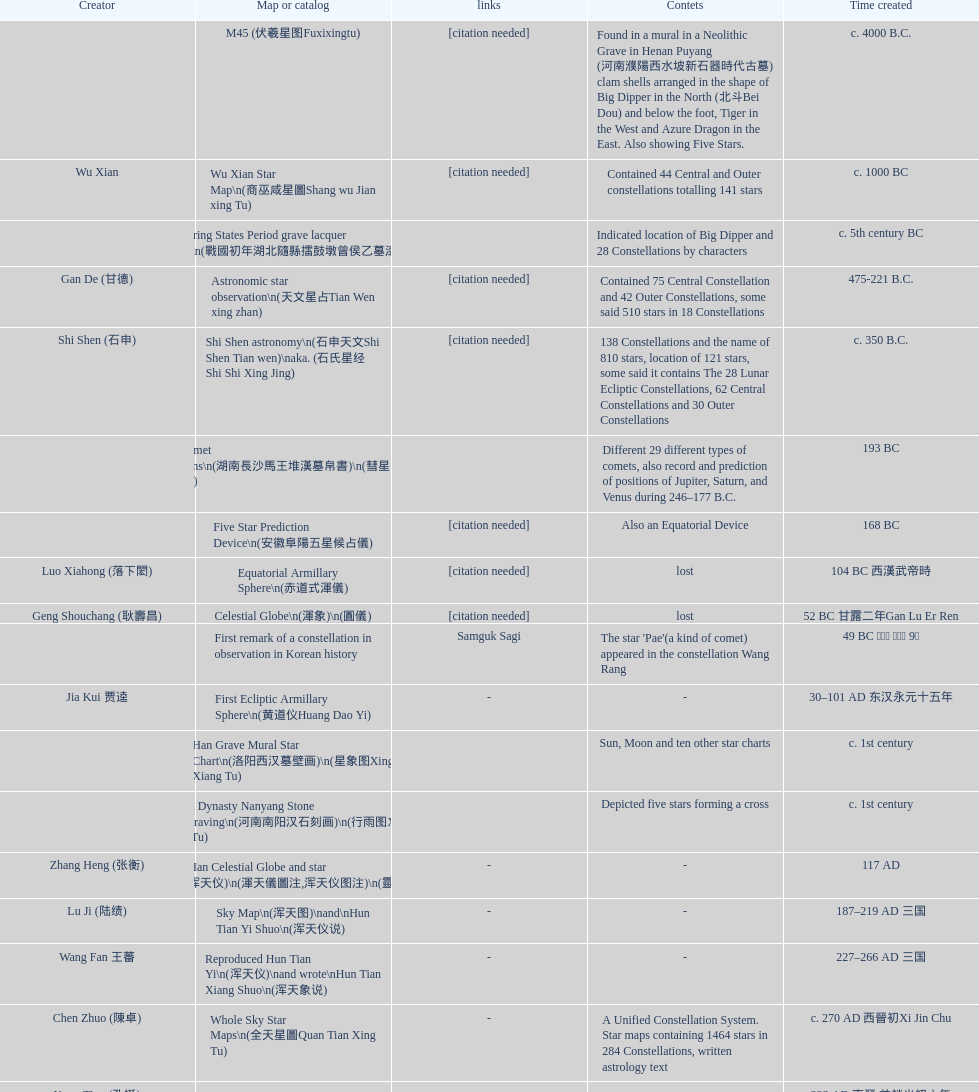When was the first map or catalog created? C. 4000 b.c. Can you parse all the data within this table? {'header': ['Creator', 'Map or catalog', 'links', 'Contets', 'Time created'], 'rows': [['', 'M45 (伏羲星图Fuxixingtu)', '[citation needed]', 'Found in a mural in a Neolithic Grave in Henan Puyang (河南濮陽西水坡新石器時代古墓) clam shells arranged in the shape of Big Dipper in the North (北斗Bei Dou) and below the foot, Tiger in the West and Azure Dragon in the East. Also showing Five Stars.', 'c. 4000 B.C.'], ['Wu Xian', 'Wu Xian Star Map\\n(商巫咸星圖Shang wu Jian xing Tu)', '[citation needed]', 'Contained 44 Central and Outer constellations totalling 141 stars', 'c. 1000 BC'], ['', 'Warring States Period grave lacquer box\\n(戰國初年湖北隨縣擂鼓墩曾侯乙墓漆箱)', '', 'Indicated location of Big Dipper and 28 Constellations by characters', 'c. 5th century BC'], ['Gan De (甘德)', 'Astronomic star observation\\n(天文星占Tian Wen xing zhan)', '[citation needed]', 'Contained 75 Central Constellation and 42 Outer Constellations, some said 510 stars in 18 Constellations', '475-221 B.C.'], ['Shi Shen (石申)', 'Shi Shen astronomy\\n(石申天文Shi Shen Tian wen)\\naka. (石氏星经 Shi Shi Xing Jing)', '[citation needed]', '138 Constellations and the name of 810 stars, location of 121 stars, some said it contains The 28 Lunar Ecliptic Constellations, 62 Central Constellations and 30 Outer Constellations', 'c. 350 B.C.'], ['', 'Han Comet Diagrams\\n(湖南長沙馬王堆漢墓帛書)\\n(彗星圖Meng xing Tu)', '', 'Different 29 different types of comets, also record and prediction of positions of Jupiter, Saturn, and Venus during 246–177 B.C.', '193 BC'], ['', 'Five Star Prediction Device\\n(安徽阜陽五星候占儀)', '[citation needed]', 'Also an Equatorial Device', '168 BC'], ['Luo Xiahong (落下閎)', 'Equatorial Armillary Sphere\\n(赤道式渾儀)', '[citation needed]', 'lost', '104 BC 西漢武帝時'], ['Geng Shouchang (耿壽昌)', 'Celestial Globe\\n(渾象)\\n(圓儀)', '[citation needed]', 'lost', '52 BC 甘露二年Gan Lu Er Ren'], ['', 'First remark of a constellation in observation in Korean history', 'Samguk Sagi', "The star 'Pae'(a kind of comet) appeared in the constellation Wang Rang", '49 BC 혁거세 거서간 9년'], ['Jia Kui 贾逵', 'First Ecliptic Armillary Sphere\\n(黄道仪Huang Dao Yi)', '-', '-', '30–101 AD 东汉永元十五年'], ['', 'Han Grave Mural Star Chart\\n(洛阳西汉墓壁画)\\n(星象图Xing Xiang Tu)', '', 'Sun, Moon and ten other star charts', 'c. 1st century'], ['', 'Han Dynasty Nanyang Stone Engraving\\n(河南南阳汉石刻画)\\n(行雨图Xing Yu Tu)', '', 'Depicted five stars forming a cross', 'c. 1st century'], ['Zhang Heng (张衡)', 'Eastern Han Celestial Globe and star maps\\n(浑天仪)\\n(渾天儀圖注,浑天仪图注)\\n(靈憲,灵宪)', '-', '-', '117 AD'], ['Lu Ji (陆绩)', 'Sky Map\\n(浑天图)\\nand\\nHun Tian Yi Shuo\\n(浑天仪说)', '-', '-', '187–219 AD 三国'], ['Wang Fan 王蕃', 'Reproduced Hun Tian Yi\\n(浑天仪)\\nand wrote\\nHun Tian Xiang Shuo\\n(浑天象说)', '-', '-', '227–266 AD 三国'], ['Chen Zhuo (陳卓)', 'Whole Sky Star Maps\\n(全天星圖Quan Tian Xing Tu)', '-', 'A Unified Constellation System. Star maps containing 1464 stars in 284 Constellations, written astrology text', 'c. 270 AD 西晉初Xi Jin Chu'], ['Kong Ting (孔挺)', 'Equatorial Armillary Sphere\\n(渾儀Hun Xi)', '-', 'level being used in this kind of device', '323 AD 東晉 前趙光初六年'], ['Hu Lan (斛蘭)', 'Northern Wei Period Iron Armillary Sphere\\n(鐵渾儀)', '', '-', 'Bei Wei\\plevel being used in this kind of device'], ['Qian Lezhi (錢樂之)', 'Southern Dynasties Period Whole Sky Planetarium\\n(渾天象Hun Tian Xiang)', '-', 'used red, black and white to differentiate stars from different star maps from Shi Shen, Gan De and Wu Xian 甘, 石, 巫三家星', '443 AD 南朝劉宋元嘉年間'], ['', 'Northern Wei Grave Dome Star Map\\n(河南洛陽北魏墓頂星圖)', '', 'about 300 stars, including the Big Dipper, some stars are linked by straight lines to form constellation. The Milky Way is also shown.', '526 AD 北魏孝昌二年'], ['Geng Xun (耿詢)', 'Water-powered Planetarium\\n(水力渾天儀)', '-', '-', 'c. 7th century 隋初Sui Chu'], ['Yu Jicai (庾季才) and Zhou Fen (周墳)', 'Lingtai Miyuan\\n(靈台秘苑)', '-', 'incorporated star maps from different sources', '604 AD 隋Sui'], ['Li Chunfeng 李淳風', 'Tang Dynasty Whole Sky Ecliptic Armillary Sphere\\n(渾天黃道儀)', '-', 'including Elliptic and Moon orbit, in addition to old equatorial design', '667 AD 貞觀七年'], ['Dun Huang', 'The Dunhuang star map\\n(燉煌)', '', '1,585 stars grouped into 257 clusters or "asterisms"', '705–710 AD'], ['', 'Turfan Tomb Star Mural\\n(新疆吐鲁番阿斯塔那天文壁画)', '', '28 Constellations, Milkyway and Five Stars', '250–799 AD 唐'], ['', 'Picture of Fuxi and Nüwa 新疆阿斯達那唐墓伏羲Fu Xi 女媧NV Wa像Xiang', 'Image:Nuva fuxi.gif', 'Picture of Fuxi and Nuwa together with some constellations', 'Tang Dynasty'], ['Yixing Monk 一行和尚 (张遂)Zhang Sui and Liang Lingzan 梁令瓚', 'Tang Dynasty Armillary Sphere\\n(唐代渾儀Tang Dai Hun Xi)\\n(黃道遊儀Huang dao you xi)', '', 'based on Han Dynasty Celestial Globe, recalibrated locations of 150 stars, determined that stars are moving', '683–727 AD'], ['Yixing Priest 一行和尚 (张遂)\\pZhang Sui\\p683–727 AD', 'Tang Dynasty Indian Horoscope Chart\\n(梵天火羅九曜)', '', '', 'simple diagrams of the 28 Constellation'], ['', 'Kitora Kofun 法隆寺FaLong Si\u3000キトラ古墳 in Japan', '', 'Detailed whole sky map', 'c. late 7th century – early 8th century'], ['Gautama Siddha', 'Treatise on Astrology of the Kaiyuan Era\\n(開元占経,开元占经Kai Yuan zhang Jing)', '-', 'Collection of the three old star charts from Shi Shen, Gan De and Wu Xian. One of the most renowned collection recognized academically.', '713 AD –'], ['', 'Big Dipper\\n(山東嘉祥武梁寺石刻北斗星)', '', 'showing stars in Big Dipper', '–'], ['', 'Prajvalonisa Vjrabhairava Padvinasa-sri-dharani Scroll found in Japan 熾盛光佛頂大威德銷災吉祥陀羅尼經卷首扉畫', '-', 'Chinese 28 Constellations and Western Zodiac', '972 AD 北宋開寶五年'], ['', 'Tangut Khara-Khoto (The Black City) Star Map 西夏黑水城星圖', '-', 'A typical Qian Lezhi Style Star Map', '940 AD'], ['', 'Star Chart 五代吳越文穆王前元瓘墓石刻星象圖', '', '-', '941–960 AD'], ['', 'Ancient Star Map 先天图 by 陈抟Chen Tuan', 'Lost', 'Perhaps based on studying of Puyong Ancient Star Map', 'c. 11th Chen Tuan 宋Song'], ['Han Xianfu 韓顯符', 'Song Dynasty Bronze Armillary Sphere 北宋至道銅渾儀', '-', 'Similar to the Simplified Armillary by Kong Ting 孔挺, 晁崇 Chao Chong, 斛蘭 Hu Lan', '1006 AD 宋道元年十二月'], ['Shu Yijian 舒易簡, Yu Yuan 于渊, Zhou Cong 周琮', 'Song Dynasty Bronze Armillary Sphere 北宋天文院黄道渾儀', '-', 'Similar to the Armillary by Tang Dynasty Liang Lingzan 梁令瓚 and Yi Xing 一行', '宋皇祐年中'], ['Shen Kuo 沈括 and Huangfu Yu 皇甫愈', 'Song Dynasty Armillary Sphere 北宋簡化渾儀', '-', 'Simplied version of Tang Dynasty Device, removed the rarely used moon orbit.', '1089 AD 熙寧七年'], ['Su Song 蘇頌', 'Five Star Charts (新儀象法要)', 'Image:Su Song Star Map 1.JPG\\nImage:Su Song Star Map 2.JPG', '1464 stars grouped into 283 asterisms', '1094 AD'], ['Su Song 蘇頌 and Han Gonglian 韩公廉', 'Song Dynasty Water-powered Planetarium 宋代 水运仪象台', '', '-', 'c. 11th century'], ['', 'Liao Dynasty Tomb Dome Star Map 遼宣化张世卿墓頂星圖', '', 'shown both the Chinese 28 Constellation encircled by Babylonian Zodiac', '1116 AD 遼天庆六年'], ['', "Star Map in a woman's grave (江西德安 南宋周氏墓星相图)", '', 'Milky Way and 57 other stars.', '1127–1279 AD'], ['Huang Shang (黃裳)', 'Hun Tian Yi Tong Xing Xiang Quan Tu, Suzhou Star Chart (蘇州石刻天文圖),淳祐天文図', '', '1434 Stars grouped into 280 Asterisms in Northern Sky map', 'created in 1193, etched to stone in 1247 by Wang Zhi Yuan 王致遠'], ['Guo Shou Jing 郭守敬', 'Yuan Dynasty Simplified Armillary Sphere 元代簡儀', '', 'Further simplied version of Song Dynasty Device', '1276–1279'], ['', 'Japanese Star Chart 格子月進図', '', 'Similar to Su Song Star Chart, original burned in air raids during World War II, only pictures left. Reprinted in 1984 by 佐佐木英治', '1324'], ['', '天象列次分野之図(Cheonsang Yeolcha Bunyajido)', '', 'Korean versions of Star Map in Stone. It was made in Chosun Dynasty and the constellation names were written in Chinese letter. The constellations as this was found in Japanese later. Contained 1,464 stars.', '1395'], ['', 'Japanese Star Chart 瀧谷寺 天之図', '', '-', 'c. 14th or 15th centuries 室町中期以前'], ['', "Korean King Sejong's Armillary sphere", '', '-', '1433'], ['Mao Kun 茅坤', 'Star Chart', 'zh:郑和航海图', 'Polaris compared with Southern Cross and Alpha Centauri', 'c. 1422'], ['', 'Korean Tomb', '', 'Big Dipper', 'c. late 14th century'], ['', 'Ming Ancient Star Chart 北京隆福寺(古星圖)', '', '1420 Stars, possibly based on old star maps from Tang Dynasty', 'c. 1453 明代'], ['', 'Chanshu Star Chart (明常熟石刻天文圖)', '-', 'Based on Suzhou Star Chart, Northern Sky observed at 36.8 degrees North Latitude, 1466 stars grouped into 284 asterism', '1506'], ['Matteo Ricci 利玛窦Li Ma Dou, recorded by Li Zhizao 李之藻', 'Ming Dynasty Star Map (渾蓋通憲圖說)', '', '-', 'c. 1550'], ['Xiao Yun Cong 萧云从', 'Tian Wun Tu (天问图)', '', 'Contained mapping of 12 constellations and 12 animals', 'c. 1600'], ['by 尹真人高第弟子 published by 余永宁', 'Zhou Tian Xuan Ji Tu (周天璇玑图) and He He Si Xiang Tu (和合四象圖) in Xing Ming Gui Zhi (性命圭旨)', '', 'Drawings of Armillary Sphere and four Chinese Celestial Animals with some notes. Related to Taoism.', '1615'], ['', 'Korean Astronomy Book "Selected and Systematized Astronomy Notes" 天文類抄', '', 'Contained some star maps', '1623~1649'], ['Xu Guang ci 徐光啟 and Adam Schall von Bell Tang Ruo Wang湯若望', 'Ming Dynasty General Star Map (赤道南北兩總星圖)', '', '-', '1634'], ['Xu Guang ci 徐光啟', 'Ming Dynasty diagrams of Armillary spheres and Celestial Globes', '', '-', 'c. 1699'], ['', 'Ming Dynasty Planetarium Machine (渾象 Hui Xiang)', '', 'Ecliptic, Equator, and dividers of 28 constellation', 'c. 17th century'], ['', 'Copper Plate Star Map stored in Korea', '', '-', '1652 順治九年shun zi jiu nian'], ['Harumi Shibukawa 渋川春海Bu Chuan Chun Mei(保井春海Bao Jing Chun Mei)', 'Japanese Edo period Star Chart 天象列次之図 based on 天象列次分野之図 from Korean', '', '-', '1670 寛文十年'], ['Ferdinand Verbiest 南懷仁', 'The Celestial Globe 清康熙 天體儀', '', '1876 stars grouped into 282 asterisms', '1673'], ['Japanese painter', 'Picture depicted Song Dynasty fictional astronomer (呉用 Wu Yong) with a Celestial Globe (天體儀)', 'File:Chinese astronomer 1675.jpg', 'showing top portion of a Celestial Globe', '1675'], ['Harumi Shibukawa 渋川春海BuJingChun Mei (保井春海Bao JingChunMei)', 'Japanese Edo period Star Chart 天文分野之図', '', '-', '1677 延宝五年'], ['', 'Korean star map in stone', '', '-', '1687'], ['井口常範', 'Japanese Edo period Star Chart 天文図解', '-', '-', '1689 元禄2年'], ['苗村丈伯Mao Chun Zhang Bo', 'Japanese Edo period Star Chart 古暦便覧備考', '-', '-', '1692 元禄5年'], ['Harumi Yasui written in Chinese', 'Japanese star chart', '', 'A Japanese star chart of 1699 showing lunar stations', '1699 AD'], ['(渋川昔尹She Chuan Xi Yin) (保井昔尹Bao Jing Xi Yin)', 'Japanese Edo period Star Chart 天文成象Tian Wen Cheng xiang', '', 'including Stars from Wu Shien (44 Constellation, 144 stars) in yellow; Gan De (118 Constellations, 511 stars) in black; Shi Shen (138 Constellations, 810 stars) in red and Harumi Shibukawa (61 Constellations, 308 stars) in blue;', '1699 元禄十二年'], ['', 'Japanese Star Chart 改正天文図説', '', 'Included stars from Harumi Shibukawa', 'unknown'], ['', 'Korean Star Map Stone', '', '-', 'c. 17th century'], ['', 'Korean Star Map', '', '-', 'c. 17th century'], ['', 'Ceramic Ink Sink Cover', '', 'Showing Big Dipper', 'c. 17th century'], ['Italian Missionary Philippus Maria Grimardi 閔明我 (1639~1712)', 'Korean Star Map Cube 方星圖', '', '-', 'c. early 18th century'], ['You Zi liu 游子六', 'Star Chart preserved in Japan based on a book from China 天経或問', '', 'A Northern Sky Chart in Chinese', '1730 AD 江戸時代 享保15年'], ['', 'Star Chart 清蒙文石刻(欽天監繪製天文圖) in Mongolia', '', '1550 stars grouped into 270 starisms.', '1727–1732 AD'], ['', 'Korean Star Maps, North and South to the Eclliptic 黃道南北恒星圖', '', '-', '1742'], ['入江脩敬Ru Jiang YOu Jing', 'Japanese Edo period Star Chart 天経或問註解図巻\u3000下', '-', '-', '1750 寛延3年'], ['Dai Zhen 戴震', 'Reproduction of an ancient device 璇璣玉衡', 'Could be similar to', 'based on ancient record and his own interpretation', '1723–1777 AD'], ['', 'Rock Star Chart 清代天文石', '', 'A Star Chart and general Astronomy Text', 'c. 18th century'], ['', 'Korean Complete Star Map (渾天全圖)', '', '-', 'c. 18th century'], ['Yun Lu 允禄 and Ignatius Kogler 戴进贤Dai Jin Xian 戴進賢, a German', 'Qing Dynasty Star Catalog (儀象考成,仪象考成)恒星表 and Star Map 黄道南北両星総図', '', '300 Constellations and 3083 Stars. Referenced Star Catalogue published by John Flamsteed', 'Device made in 1744, book completed in 1757 清乾隆年间'], ['', 'Jingban Tianwen Quantu by Ma Junliang 马俊良', '', 'mapping nations to the sky', '1780–90 AD'], ['Yan Qiao Shan Bing Heng 岩橋善兵衛', 'Japanese Edo period Illustration of a Star Measuring Device 平天儀図解', 'The device could be similar to', '-', '1802 Xiang He Er Nian 享和二年'], ['Xu Choujun 徐朝俊', 'North Sky Map 清嘉庆年间Huang Dao Zhong Xi He Tu(黄道中西合图)', '', 'More than 1000 stars and the 28 consellation', '1807 AD'], ['Chao Ye Bei Shui 朝野北水', 'Japanese Edo period Star Chart 天象総星之図', '-', '-', '1814 文化十一年'], ['田中政均', 'Japanese Edo period Star Chart 新制天球星象記', '-', '-', '1815 文化十二年'], ['坂部廣胖', 'Japanese Edo period Star Chart 天球図', '-', '-', '1816 文化十三年'], ['John Reeves esq', 'Chinese Star map', '', 'Printed map showing Chinese names of stars and constellations', '1819 AD'], ['佐藤祐之', 'Japanese Edo period Star Chart 昊天図説詳解', '-', '-', '1824 文政七年'], ['小島好謙 and 鈴木世孝', 'Japanese Edo period Star Chart 星図歩天歌', '-', '-', '1824 文政七年'], ['鈴木世孝', 'Japanese Edo period Star Chart', '-', '-', '1824 文政七年'], ['長久保赤水', 'Japanese Edo period Star Chart 天象管鈔 天体図 (天文星象図解)', '', '-', '1824 文政七年'], ['足立信順Zhu Li Xin Shun', 'Japanese Edo period Star Measuring Device 中星儀', '-', '-', '1824 文政七年'], ['桜田虎門', 'Japanese Star Map 天象一覧図 in Kanji', '', 'Printed map showing Chinese names of stars and constellations', '1824 AD 文政７年'], ['', 'Korean Star Map 天象列次分野之図 in Kanji', '[18]', 'Printed map showing Chinese names of stars and constellations', 'c. 19th century'], ['', 'Korean Star Map', '', '-', 'c. 19th century, late Choson Period'], ['', 'Korean Star maps: Star Map South to the Ecliptic 黃道南恒星圖 and Star Map South to the Ecliptic 黃道北恒星圖', '', 'Perhaps influenced by Adam Schall von Bell Tang Ruo wang 湯若望 (1591–1666) and P. Ignatius Koegler 戴進賢 (1680–1748)', 'c. 19th century'], ['', 'Korean Complete map of the celestial sphere (渾天全圖)', '', '-', 'c. 19th century'], ['', 'Korean Book of Stars 經星', '', 'Several star maps', 'c. 19th century'], ['石坂常堅', 'Japanese Edo period Star Chart 方円星図,方圓星図 and 増補分度星図方図', '-', '-', '1826b文政9年'], ['伊能忠誨', 'Japanese Star Chart', '-', '-', 'c. 19th century'], ['古筆源了材', 'Japanese Edo period Star Chart 天球図説', '-', '-', '1835 天保6年'], ['', 'Qing Dynasty Star Catalog (儀象考成續編)星表', '', 'Appendix to Yi Xian Kao Cheng, listed 3240 stars (added 163, removed 6)', '1844'], ['', 'Stars map (恒星赤道経緯度図)stored in Japan', '-', '-', '1844 道光24年 or 1848'], ['藤岡有貞', 'Japanese Edo period Star Chart 経緯簡儀用法', '-', '-', '1845 弘化２年'], ['高塚福昌, 阿部比輔, 上条景弘', 'Japanese Edo period Star Chart 分野星図', '-', '-', '1849 嘉永2年'], ['遠藤盛俊', 'Japanese Late Edo period Star Chart 天文図屏風', '-', '-', 'late Edo Period 江戸時代後期'], ['三浦梅園', 'Japanese Star Chart 天体図', '-', '-', '-'], ['高橋景保', 'Japanese Star Chart 梅園星図', '', '-', '-'], ['李俊養', 'Korean Book of New Song of the Sky Pacer 新法步天歌', '', 'Star maps and a revised version of the Song of Sky Pacer', '1862'], ['', 'Stars South of Equator, Stars North of Equator (赤道南恆星圖,赤道北恆星圖)', '', 'Similar to Ming Dynasty General Star Map', '1875～1908 清末光緒年間'], ['', 'Fuxi 64 gua 28 xu wood carving 天水市卦台山伏羲六十四卦二十八宿全图', '-', '-', 'modern'], ['', 'Korean Map of Heaven and Earth 天地圖', '', '28 Constellations and geographic map', 'c. 19th century'], ['', 'Korean version of 28 Constellation 列宿圖', '', '28 Constellations, some named differently from their Chinese counterparts', 'c. 19th century'], ['朴?', 'Korean Star Chart 渾天図', '-', '-', '-'], ['', 'Star Chart in a Dao Temple 玉皇山道觀星圖', '-', '-', '1940 AD'], ['Yi Shi Tong 伊世同', 'Simplified Chinese and Western Star Map', '', 'Star Map showing Chinese Xingquan and Western Constellation boundaries', 'Aug. 1963'], ['Yu Xi Dao Ren 玉溪道人', 'Sky Map', '', 'Star Map with captions', '1987'], ['Sun Xiaochun and Jacob Kistemaker', 'The Chinese Sky during the Han Constellating Stars and Society', '', 'An attempt to recreate night sky seen by Chinese 2000 years ago', '1997 AD'], ['', 'Star map', '', 'An attempt by a Japanese to reconstruct the night sky for a historical event around 235 AD 秋風五丈原', 'Recent'], ['', 'Star maps', '', 'Chinese 28 Constellation with Chinese and Japanese captions', 'Recent'], ['', 'SinoSky Beta 2.0', '', 'A computer program capable of showing Chinese Xingguans alongside with western constellations, lists about 700 stars with Chinese names.', '2002'], ['', 'AEEA Star maps', '', 'Good reconstruction and explanation of Chinese constellations', 'Modern'], ['', 'Wikipedia Star maps', 'zh:華蓋星', '-', 'Modern'], ['', '28 Constellations, big dipper and 4 symbols Star map', '', '-', 'Modern'], ['', 'Collection of printed star maps', '', '-', 'Modern'], ['-', '28 Xu Star map and catalog', '', 'Stars around ecliptic', 'Modern'], ['Jeong, Tae-Min(jtm71)/Chuang_Siau_Chin', 'HNSKY Korean/Chinese Supplement', '', 'Korean supplement is based on CheonSangYeulChaBunYaZiDo (B.C.100 ~ A.D.100)', 'Modern'], ['G.S.K. Lee; Jeong, Tae-Min(jtm71); Yu-Pu Wang (evanzxcv)', 'Stellarium Chinese and Korean Sky Culture', '', 'Major Xingguans and Star names', 'Modern'], ['Xi Chun Sheng Chong Hui\\p2005 redrawn, original unknown', '修真內外火侯全圖 Huo Hou Tu', '', '', 'illustrations of Milkyway and star maps, Chinese constellations in Taoism view'], ['坐井★观星Zuo Jing Guan Xing', 'Star Map with illustrations for Xingguans', '', 'illustrations for cylindrical and circular polar maps', 'Modern'], ['', 'Sky in Google Earth KML', '', 'Attempts to show Chinese Star Maps on Google Earth', 'Modern']]} 